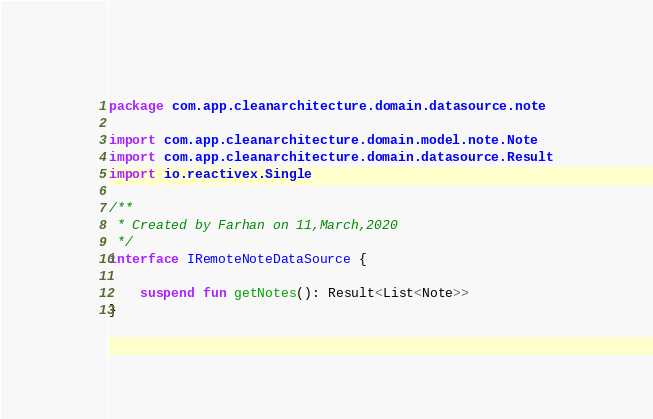Convert code to text. <code><loc_0><loc_0><loc_500><loc_500><_Kotlin_>package com.app.cleanarchitecture.domain.datasource.note

import com.app.cleanarchitecture.domain.model.note.Note
import com.app.cleanarchitecture.domain.datasource.Result
import io.reactivex.Single

/**
 * Created by Farhan on 11,March,2020
 */
interface IRemoteNoteDataSource {

    suspend fun getNotes(): Result<List<Note>>
}</code> 